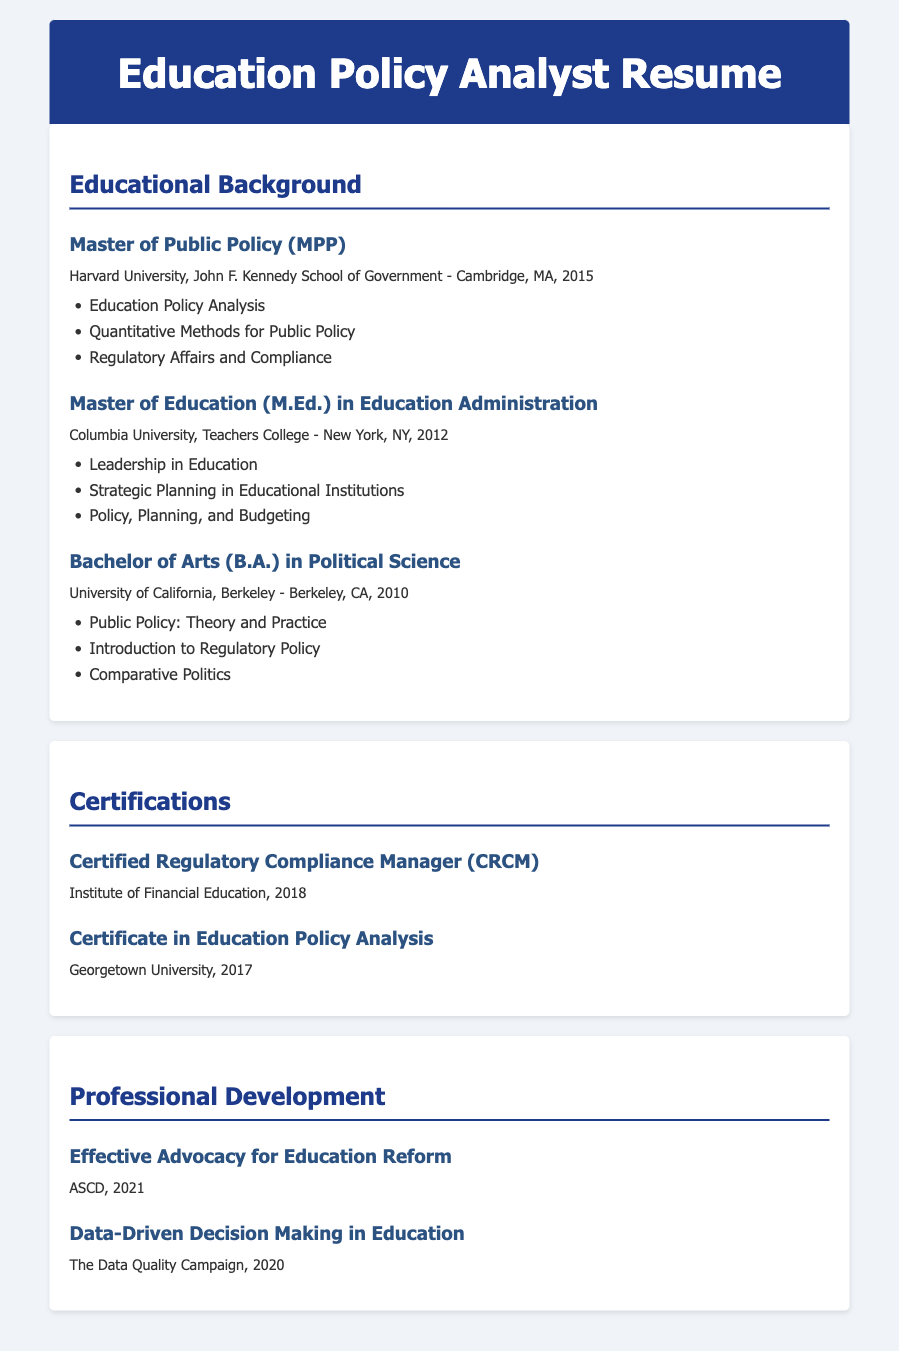What is the highest degree earned? The highest degree mentioned in the document is the Master of Public Policy from Harvard University.
Answer: Master of Public Policy In what year was the Master of Education earned? The Master of Education was earned in 2012 according to the document.
Answer: 2012 Which university awarded the Bachelor of Arts degree? The institution that awarded the Bachelor of Arts degree is the University of California, Berkeley.
Answer: University of California, Berkeley How many professional development courses are listed? There are two professional development courses highlighted in the document.
Answer: 2 What certification was obtained in 2018? The certification obtained in 2018 is the Certified Regulatory Compliance Manager.
Answer: Certified Regulatory Compliance Manager Which course focuses on advocacy for education reform? The course that focuses on advocacy for education reform is titled "Effective Advocacy for Education Reform."
Answer: Effective Advocacy for Education Reform What is a key focus area of the MPP program? A key focus area of the MPP program is Regulatory Affairs and Compliance.
Answer: Regulatory Affairs and Compliance What year did the Certificate in Education Policy Analysis get awarded? The Certificate in Education Policy Analysis was awarded in 2017.
Answer: 2017 Which university offered the course on Data-Driven Decision Making? The course on Data-Driven Decision Making was offered by The Data Quality Campaign.
Answer: The Data Quality Campaign 